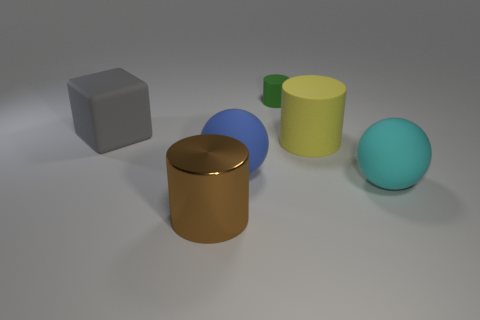Is there any other thing that has the same material as the brown thing?
Ensure brevity in your answer.  No. What number of other large matte things have the same shape as the blue matte thing?
Your answer should be compact. 1. What is the material of the cylinder that is the same size as the yellow object?
Make the answer very short. Metal. Is there a small brown thing made of the same material as the cyan thing?
Provide a short and direct response. No. Is the number of big yellow matte things to the left of the gray object less than the number of small cyan rubber balls?
Your answer should be very brief. No. What material is the large ball in front of the big rubber sphere on the left side of the large cyan matte sphere?
Give a very brief answer. Rubber. There is a thing that is both behind the large blue sphere and left of the blue thing; what shape is it?
Offer a very short reply. Cube. How many other things are the same color as the small matte cylinder?
Your answer should be compact. 0. What number of objects are big spheres that are to the right of the big blue matte sphere or small gray metallic blocks?
Keep it short and to the point. 1. Is there anything else that has the same size as the green matte cylinder?
Provide a succinct answer. No. 